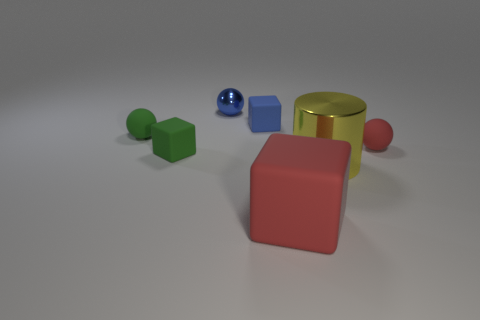How many other objects are the same shape as the large yellow shiny thing?
Provide a succinct answer. 0. What number of tiny blue spheres are in front of the big red object?
Offer a very short reply. 0. There is a sphere to the left of the small metallic thing; is its size the same as the cube left of the tiny blue cube?
Make the answer very short. Yes. What number of other things are there of the same size as the blue metal sphere?
Ensure brevity in your answer.  4. What is the small sphere that is behind the green rubber thing behind the tiny rubber object on the right side of the large red block made of?
Keep it short and to the point. Metal. There is a cylinder; is it the same size as the red thing behind the large red matte object?
Offer a very short reply. No. How big is the ball that is in front of the tiny shiny object and left of the yellow object?
Ensure brevity in your answer.  Small. Is there a tiny object of the same color as the large rubber block?
Your response must be concise. Yes. What color is the metal cylinder that is to the left of the red object right of the red cube?
Your answer should be compact. Yellow. Are there fewer blue rubber things behind the blue block than small blue blocks that are in front of the large red cube?
Provide a succinct answer. No. 